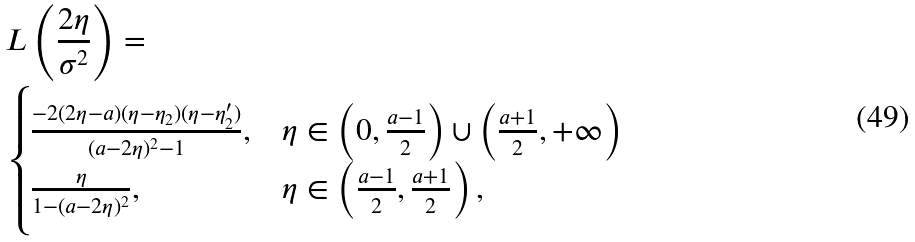<formula> <loc_0><loc_0><loc_500><loc_500>& L \left ( \frac { 2 \eta } { \sigma ^ { 2 } } \right ) = \\ & \begin{cases} \frac { - 2 ( 2 \eta - a ) ( \eta - \eta _ { 2 } ) ( \eta - \eta _ { 2 } ^ { \prime } ) } { ( a - 2 \eta ) ^ { 2 } - 1 } , & \eta \in \left ( 0 , \frac { a - 1 } { 2 } \right ) \cup \left ( \frac { a + 1 } { 2 } , + \infty \right ) \\ \frac { \eta } { 1 - ( a - 2 \eta ) ^ { 2 } } , & \eta \in \left ( \frac { a - 1 } { 2 } , \frac { a + 1 } { 2 } \right ) , \end{cases}</formula> 